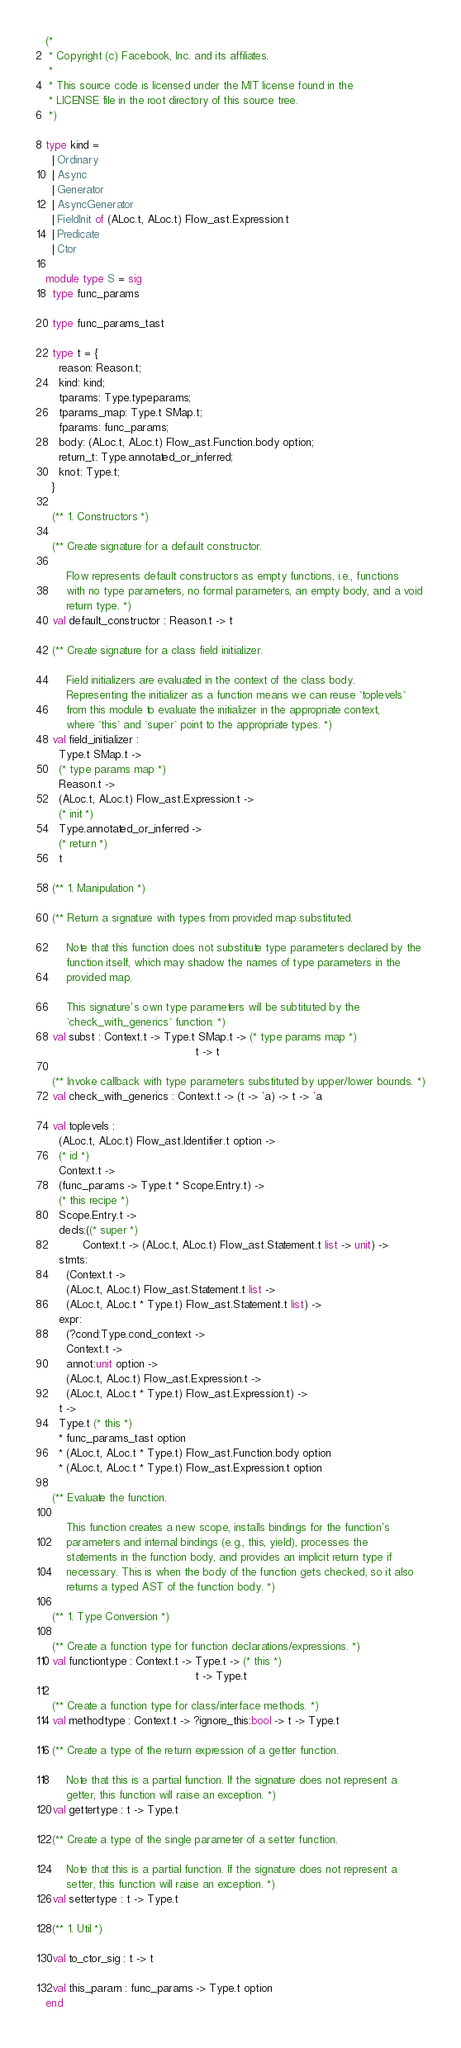<code> <loc_0><loc_0><loc_500><loc_500><_OCaml_>(*
 * Copyright (c) Facebook, Inc. and its affiliates.
 *
 * This source code is licensed under the MIT license found in the
 * LICENSE file in the root directory of this source tree.
 *)

type kind =
  | Ordinary
  | Async
  | Generator
  | AsyncGenerator
  | FieldInit of (ALoc.t, ALoc.t) Flow_ast.Expression.t
  | Predicate
  | Ctor

module type S = sig
  type func_params

  type func_params_tast

  type t = {
    reason: Reason.t;
    kind: kind;
    tparams: Type.typeparams;
    tparams_map: Type.t SMap.t;
    fparams: func_params;
    body: (ALoc.t, ALoc.t) Flow_ast.Function.body option;
    return_t: Type.annotated_or_inferred;
    knot: Type.t;
  }

  (** 1. Constructors *)

  (** Create signature for a default constructor.

      Flow represents default constructors as empty functions, i.e., functions
      with no type parameters, no formal parameters, an empty body, and a void
      return type. *)
  val default_constructor : Reason.t -> t

  (** Create signature for a class field initializer.

      Field initializers are evaluated in the context of the class body.
      Representing the initializer as a function means we can reuse `toplevels`
      from this module to evaluate the initializer in the appropriate context,
      where `this` and `super` point to the appropriate types. *)
  val field_initializer :
    Type.t SMap.t ->
    (* type params map *)
    Reason.t ->
    (ALoc.t, ALoc.t) Flow_ast.Expression.t ->
    (* init *)
    Type.annotated_or_inferred ->
    (* return *)
    t

  (** 1. Manipulation *)

  (** Return a signature with types from provided map substituted.

      Note that this function does not substitute type parameters declared by the
      function itself, which may shadow the names of type parameters in the
      provided map.

      This signature's own type parameters will be subtituted by the
      `check_with_generics` function. *)
  val subst : Context.t -> Type.t SMap.t -> (* type params map *)
                                            t -> t

  (** Invoke callback with type parameters substituted by upper/lower bounds. *)
  val check_with_generics : Context.t -> (t -> 'a) -> t -> 'a

  val toplevels :
    (ALoc.t, ALoc.t) Flow_ast.Identifier.t option ->
    (* id *)
    Context.t ->
    (func_params -> Type.t * Scope.Entry.t) ->
    (* this recipe *)
    Scope.Entry.t ->
    decls:((* super *)
           Context.t -> (ALoc.t, ALoc.t) Flow_ast.Statement.t list -> unit) ->
    stmts:
      (Context.t ->
      (ALoc.t, ALoc.t) Flow_ast.Statement.t list ->
      (ALoc.t, ALoc.t * Type.t) Flow_ast.Statement.t list) ->
    expr:
      (?cond:Type.cond_context ->
      Context.t ->
      annot:unit option ->
      (ALoc.t, ALoc.t) Flow_ast.Expression.t ->
      (ALoc.t, ALoc.t * Type.t) Flow_ast.Expression.t) ->
    t ->
    Type.t (* this *)
    * func_params_tast option
    * (ALoc.t, ALoc.t * Type.t) Flow_ast.Function.body option
    * (ALoc.t, ALoc.t * Type.t) Flow_ast.Expression.t option

  (** Evaluate the function.

      This function creates a new scope, installs bindings for the function's
      parameters and internal bindings (e.g., this, yield), processes the
      statements in the function body, and provides an implicit return type if
      necessary. This is when the body of the function gets checked, so it also
      returns a typed AST of the function body. *)

  (** 1. Type Conversion *)

  (** Create a function type for function declarations/expressions. *)
  val functiontype : Context.t -> Type.t -> (* this *)
                                            t -> Type.t

  (** Create a function type for class/interface methods. *)
  val methodtype : Context.t -> ?ignore_this:bool -> t -> Type.t

  (** Create a type of the return expression of a getter function.

      Note that this is a partial function. If the signature does not represent a
      getter, this function will raise an exception. *)
  val gettertype : t -> Type.t

  (** Create a type of the single parameter of a setter function.

      Note that this is a partial function. If the signature does not represent a
      setter, this function will raise an exception. *)
  val settertype : t -> Type.t

  (** 1. Util *)

  val to_ctor_sig : t -> t

  val this_param : func_params -> Type.t option
end
</code> 